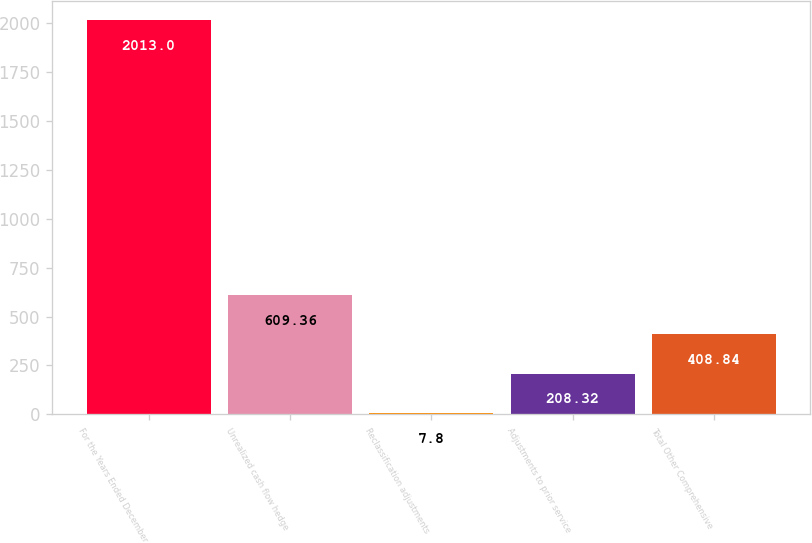<chart> <loc_0><loc_0><loc_500><loc_500><bar_chart><fcel>For the Years Ended December<fcel>Unrealized cash flow hedge<fcel>Reclassification adjustments<fcel>Adjustments to prior service<fcel>Total Other Comprehensive<nl><fcel>2013<fcel>609.36<fcel>7.8<fcel>208.32<fcel>408.84<nl></chart> 